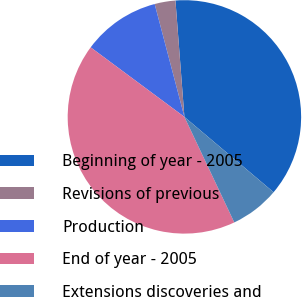Convert chart. <chart><loc_0><loc_0><loc_500><loc_500><pie_chart><fcel>Beginning of year - 2005<fcel>Revisions of previous<fcel>Production<fcel>End of year - 2005<fcel>Extensions discoveries and<nl><fcel>37.39%<fcel>2.88%<fcel>10.74%<fcel>42.19%<fcel>6.81%<nl></chart> 